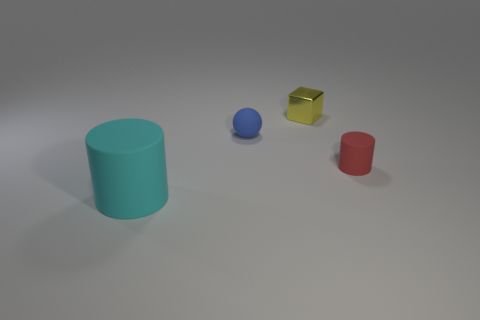Does the rubber cylinder on the left side of the blue thing have the same size as the metal block?
Your answer should be very brief. No. There is a blue thing that is the same size as the red matte cylinder; what material is it?
Your response must be concise. Rubber. Is there a rubber thing left of the rubber cylinder to the left of the small thing to the left of the tiny yellow metal object?
Your answer should be compact. No. Is there any other thing that has the same shape as the metallic thing?
Make the answer very short. No. Are there any big gray cubes?
Ensure brevity in your answer.  No. What is the size of the object that is in front of the cylinder right of the cylinder that is to the left of the red matte object?
Offer a very short reply. Large. There is a red rubber object; is its shape the same as the small object to the left of the tiny yellow object?
Your answer should be compact. No. What number of blocks are rubber objects or small yellow objects?
Your answer should be very brief. 1. Are there any other metallic objects of the same shape as the yellow metallic object?
Your answer should be compact. No. How many other things are the same color as the sphere?
Provide a short and direct response. 0. 